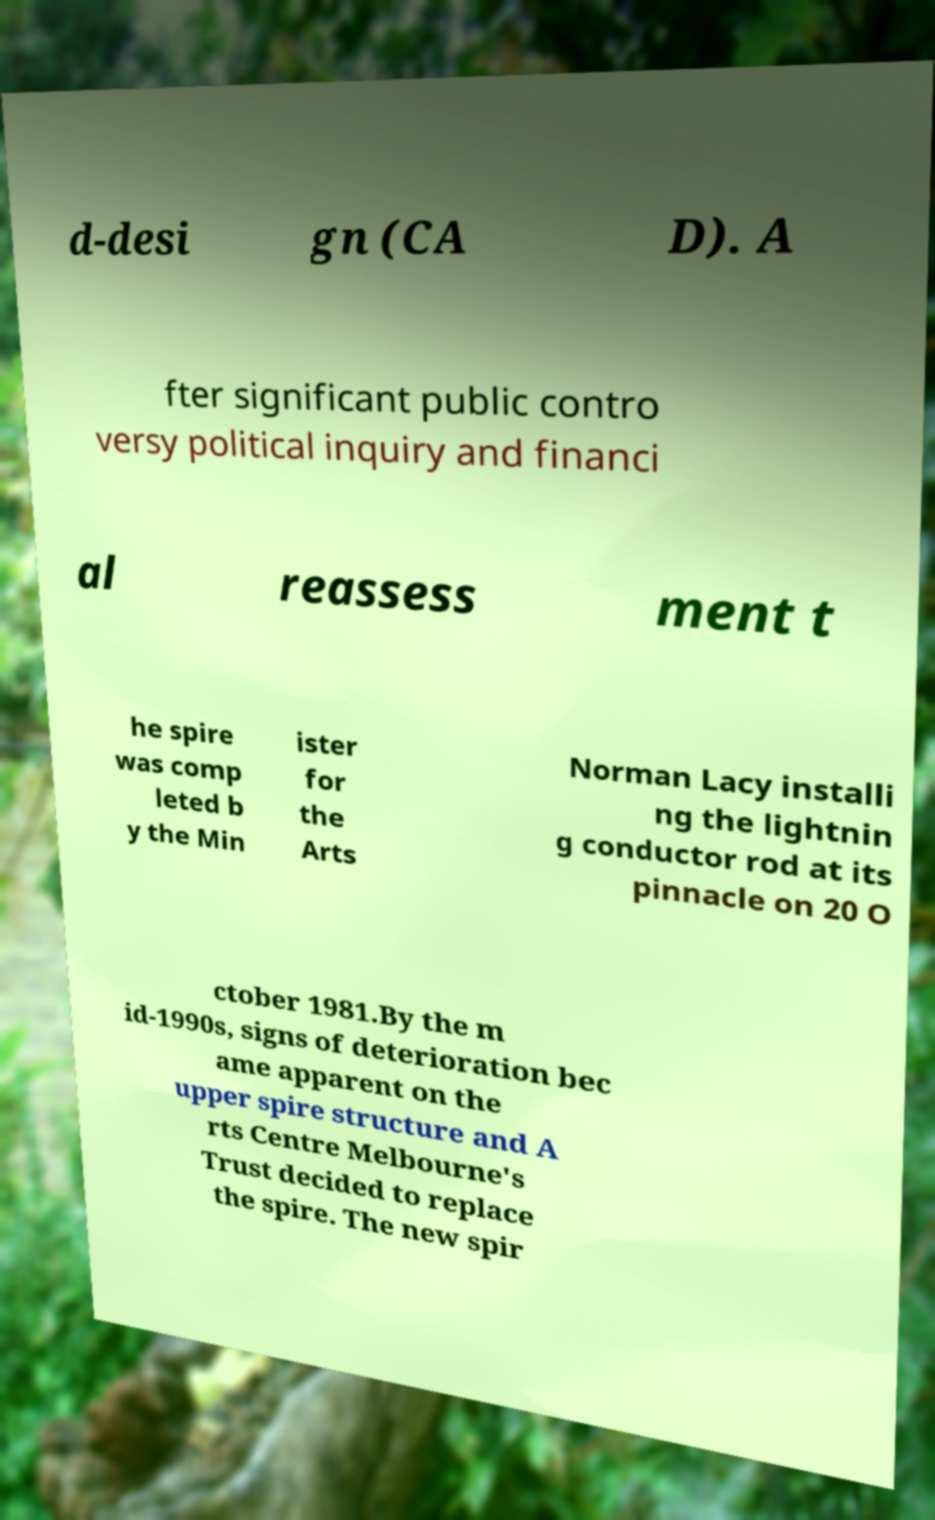I need the written content from this picture converted into text. Can you do that? d-desi gn (CA D). A fter significant public contro versy political inquiry and financi al reassess ment t he spire was comp leted b y the Min ister for the Arts Norman Lacy installi ng the lightnin g conductor rod at its pinnacle on 20 O ctober 1981.By the m id-1990s, signs of deterioration bec ame apparent on the upper spire structure and A rts Centre Melbourne's Trust decided to replace the spire. The new spir 